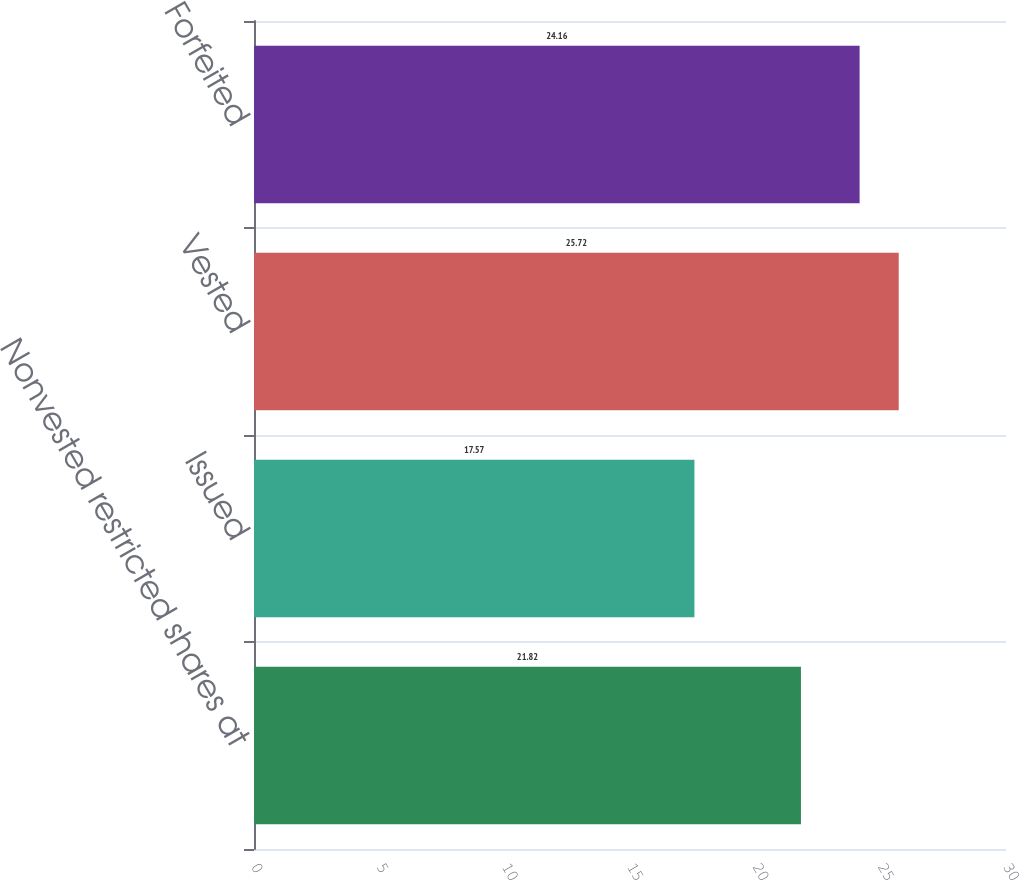Convert chart to OTSL. <chart><loc_0><loc_0><loc_500><loc_500><bar_chart><fcel>Nonvested restricted shares at<fcel>Issued<fcel>Vested<fcel>Forfeited<nl><fcel>21.82<fcel>17.57<fcel>25.72<fcel>24.16<nl></chart> 